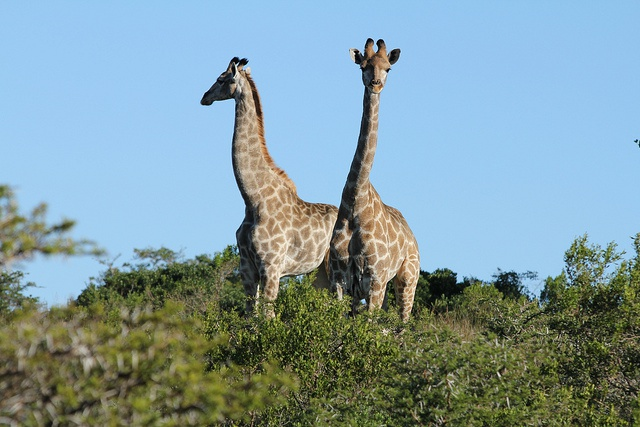Describe the objects in this image and their specific colors. I can see giraffe in lightblue, tan, and black tones and giraffe in lightblue, black, tan, and gray tones in this image. 